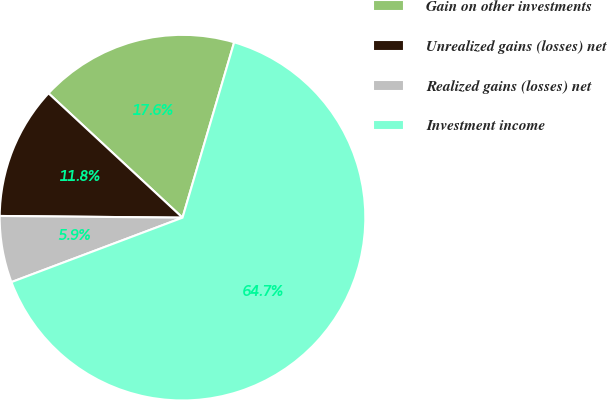Convert chart. <chart><loc_0><loc_0><loc_500><loc_500><pie_chart><fcel>Gain on other investments<fcel>Unrealized gains (losses) net<fcel>Realized gains (losses) net<fcel>Investment income<nl><fcel>17.65%<fcel>11.76%<fcel>5.88%<fcel>64.71%<nl></chart> 